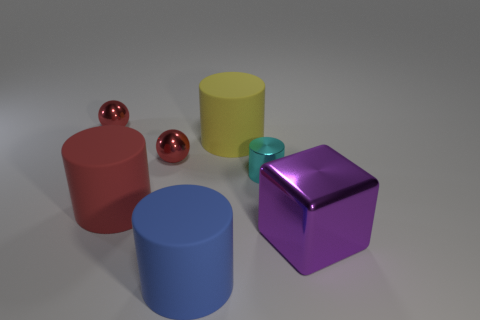Add 1 big purple matte cylinders. How many objects exist? 8 Subtract all blocks. How many objects are left? 6 Subtract all tiny yellow rubber spheres. Subtract all yellow objects. How many objects are left? 6 Add 7 small balls. How many small balls are left? 9 Add 7 purple shiny blocks. How many purple shiny blocks exist? 8 Subtract 1 red balls. How many objects are left? 6 